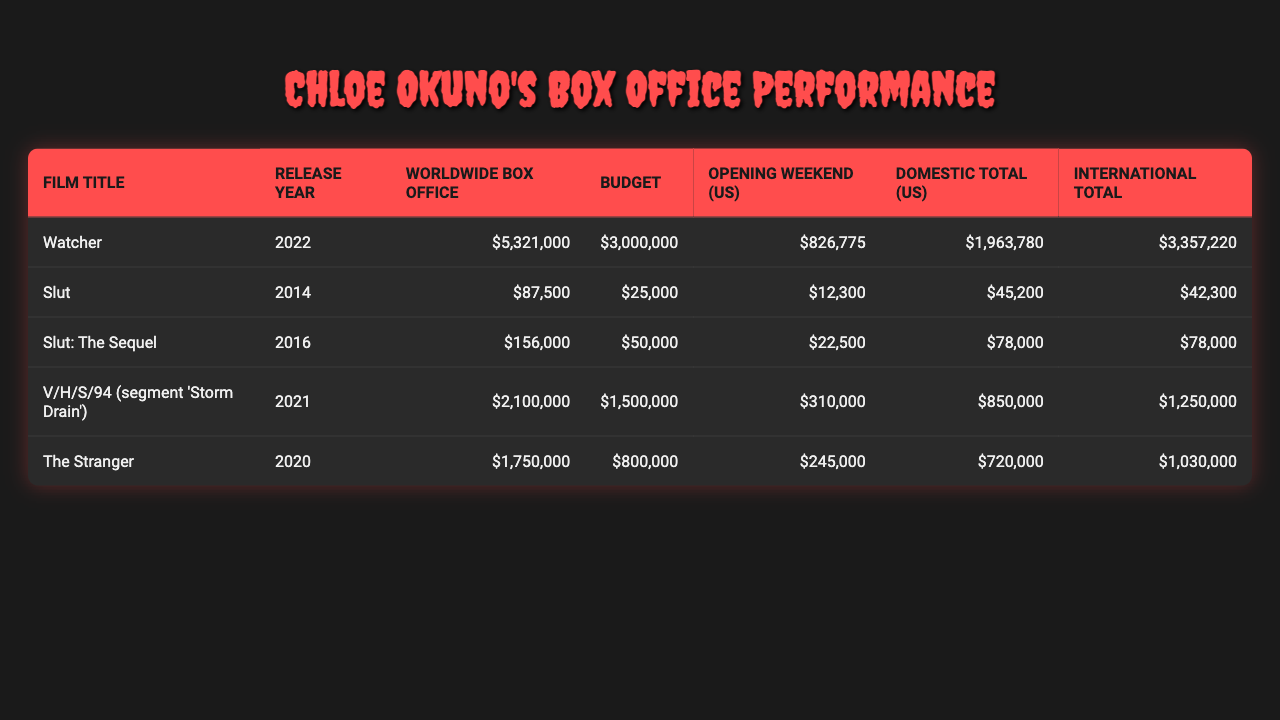What is the worldwide box office gross for "Watcher"? In the table, under the "Worldwide Box Office" column for "Watcher", the value listed is $5,321,000.
Answer: $5,321,000 What was the budget for "Slut: The Sequel"? Looking at the "Budget" column for "Slut: The Sequel", it shows the amount is $50,000.
Answer: $50,000 Which film had the highest opening weekend box office in the US? By checking the "Opening Weekend (US)" column, "Watcher" has the highest value at $826,775 compared to others.
Answer: Watcher What is the total domestic box office for "The Stranger"? The "Domestic Total (US)" column for "The Stranger" indicates the amount is $720,000.
Answer: $720,000 How much did "Slut" gross internationally? The "International Total" column for "Slut" shows a figure of $42,300.
Answer: $42,300 What is the total box office revenue for all films combined? Adding all the worldwide box office figures: $5,321,000 (Watcher) + $87,500 (Slut) + $156,000 (Slut: The Sequel) + $2,100,000 (V/H/S/94) + $1,750,000 (The Stranger) gives a total of $9,414,500.
Answer: $9,414,500 Did any film have a budget greater than its worldwide box office gross? "Slut" has a budget of $25,000 and grossed only $87,500, meaning its budget was less than gross. However, "V/H/S/94" had a budget of $1,500,000 but grossed $2,100,000, indicating no film exceeded budget in gross.
Answer: No Which film had the lowest worldwide box office? The lowest value under "Worldwide Box Office" is for "Slut" with $87,500.
Answer: Slut If you combine the domestic and international totals for "Watcher", what would the total be? The domestic total for "Watcher" is $1,963,780 and the international total is $3,357,220. Adding these together results in $1,963,780 + $3,357,220 = $5,321,000.
Answer: $5,321,000 What percentage of the budget for "The Stranger" was its worldwide gross? The budget for "The Stranger" is $800,000 and its worldwide gross is $1,750,000. The percentage is calculated as ($1,750,000 / $800,000) * 100, which equals 218.75%.
Answer: 218.75% 